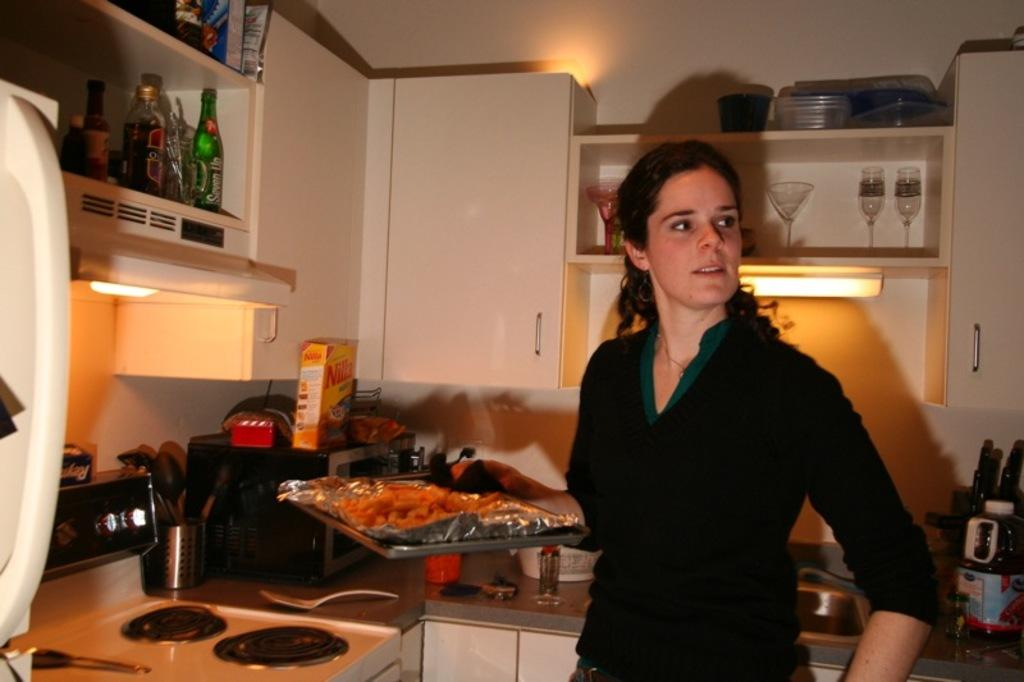<image>
Describe the image concisely. A box of Nilla wafers on the counter behind the woman 